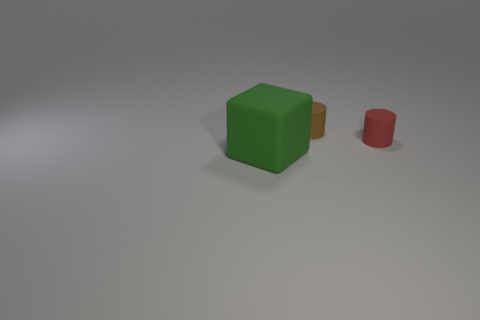What is the large green cube made of?
Ensure brevity in your answer.  Rubber. What number of matte things are blocks or small cyan balls?
Your response must be concise. 1. Is the number of green blocks right of the large green block less than the number of small brown objects that are right of the small brown rubber cylinder?
Make the answer very short. No. Is there a tiny red rubber thing that is behind the thing in front of the small object that is to the right of the brown object?
Offer a terse response. Yes. There is a small matte thing behind the red matte cylinder; is it the same shape as the small thing in front of the brown rubber object?
Your answer should be compact. Yes. What is the material of the other thing that is the same size as the red object?
Give a very brief answer. Rubber. Are the tiny thing that is in front of the tiny brown object and the object to the left of the brown cylinder made of the same material?
Give a very brief answer. Yes. There is another rubber thing that is the same size as the brown rubber object; what shape is it?
Your answer should be very brief. Cylinder. What number of other things are the same color as the large rubber thing?
Offer a terse response. 0. There is a tiny rubber cylinder behind the red cylinder; what color is it?
Provide a short and direct response. Brown. 